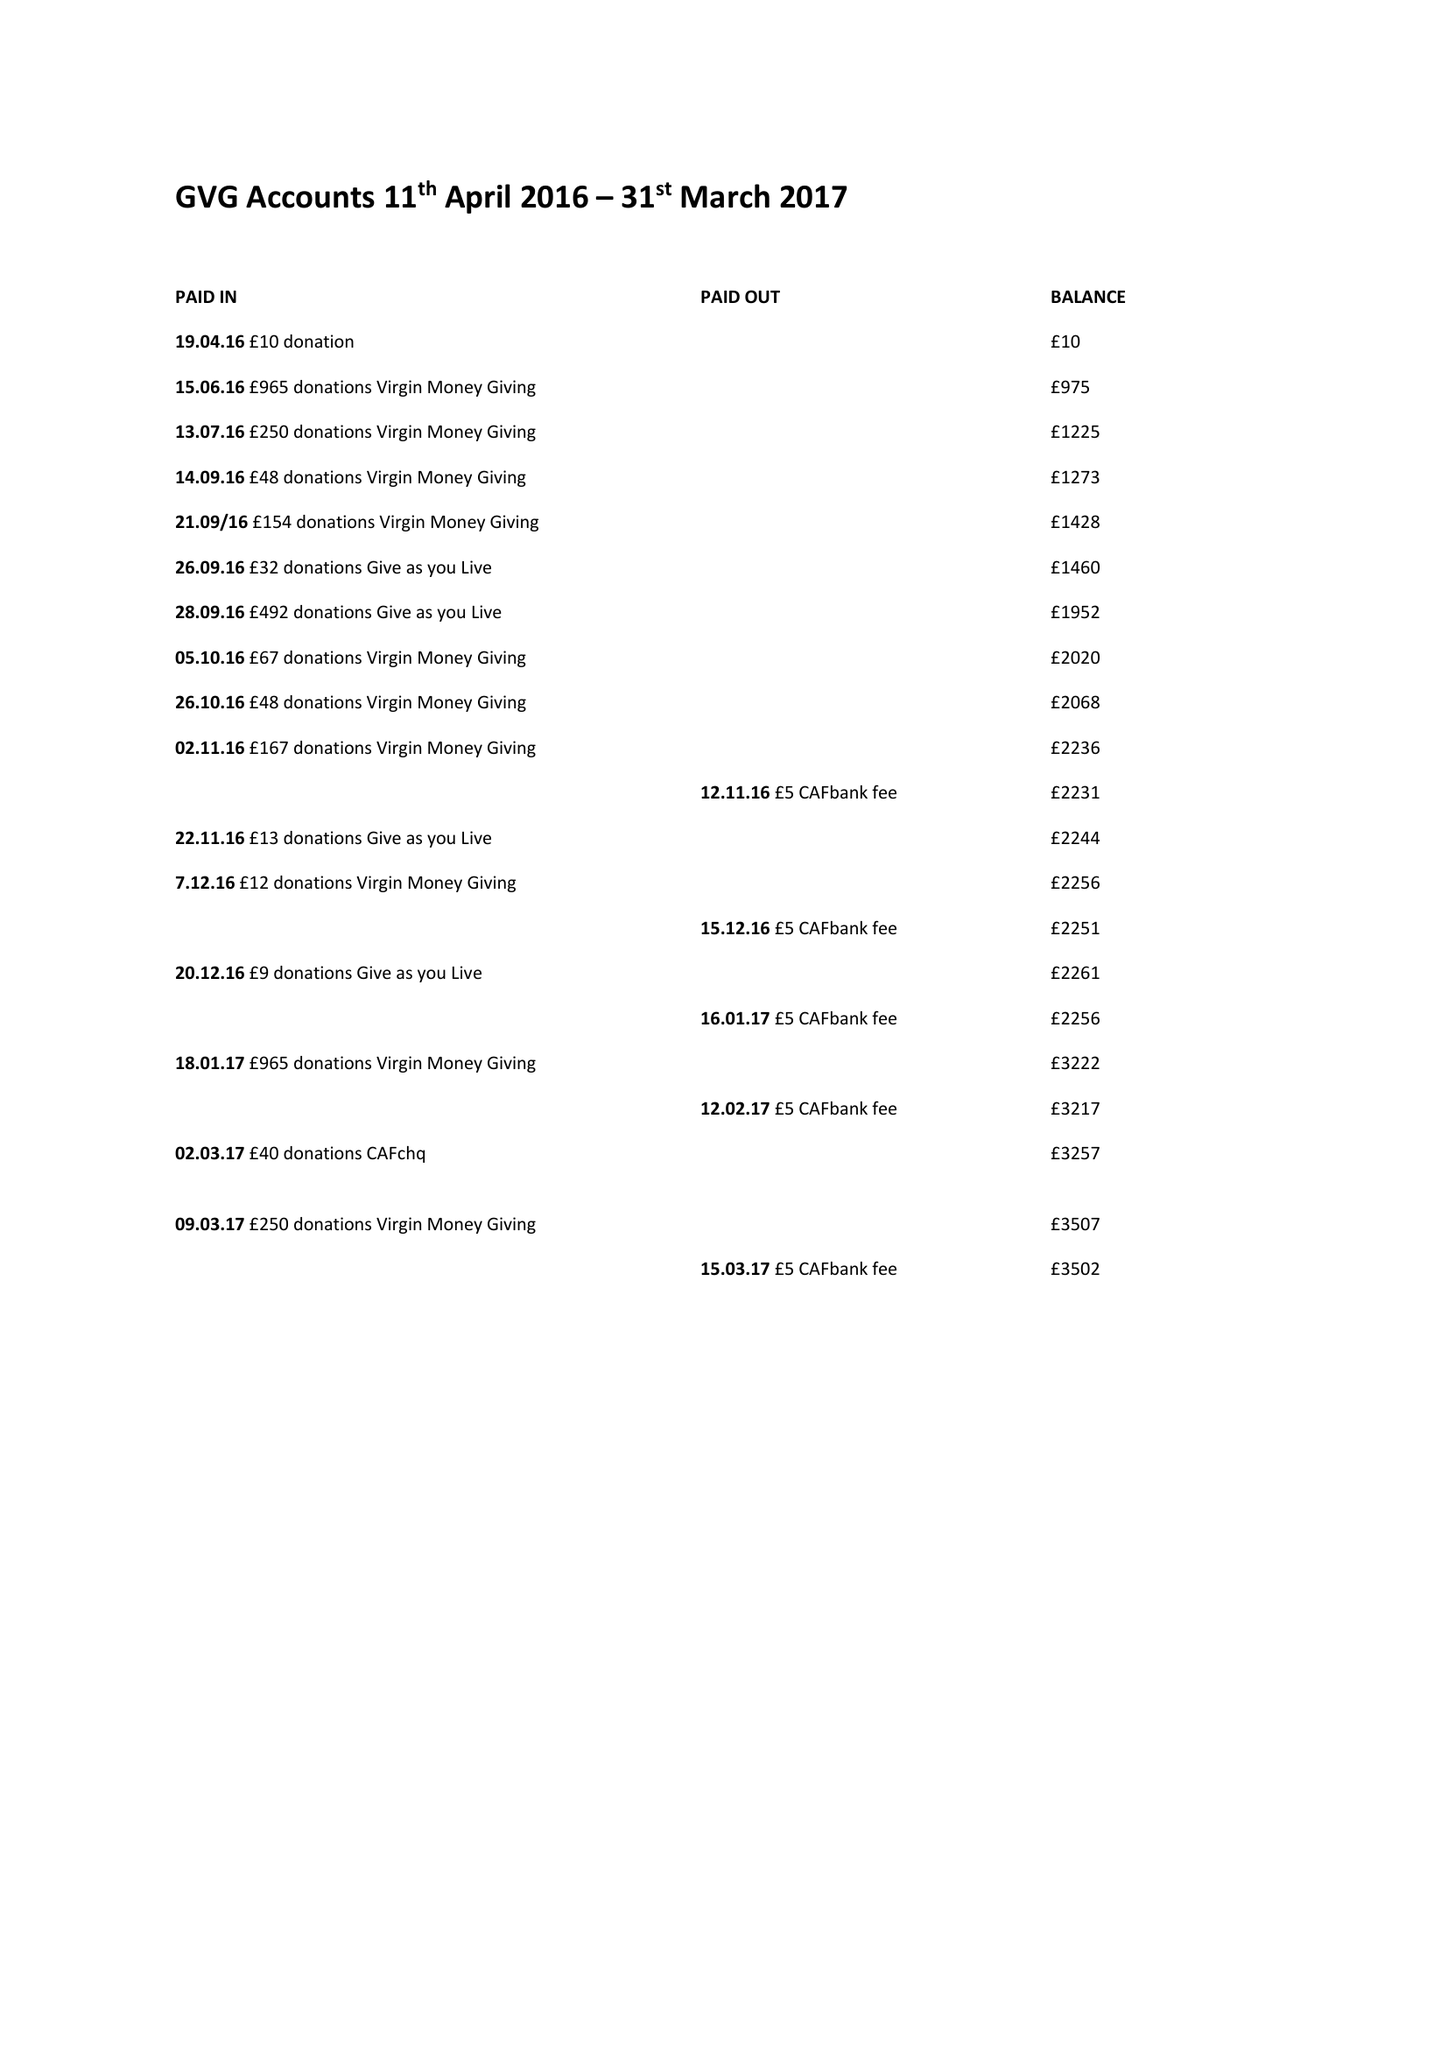What is the value for the income_annually_in_british_pounds?
Answer the question using a single word or phrase. 3527.00 